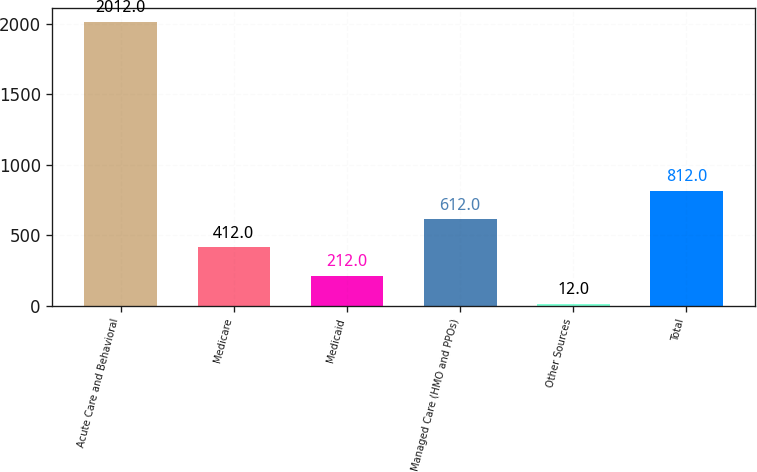<chart> <loc_0><loc_0><loc_500><loc_500><bar_chart><fcel>Acute Care and Behavioral<fcel>Medicare<fcel>Medicaid<fcel>Managed Care (HMO and PPOs)<fcel>Other Sources<fcel>Total<nl><fcel>2012<fcel>412<fcel>212<fcel>612<fcel>12<fcel>812<nl></chart> 